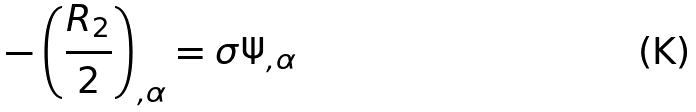Convert formula to latex. <formula><loc_0><loc_0><loc_500><loc_500>- \left ( \frac { R _ { 2 } } 2 \right ) _ { , \alpha } = \sigma \Psi _ { , \alpha }</formula> 